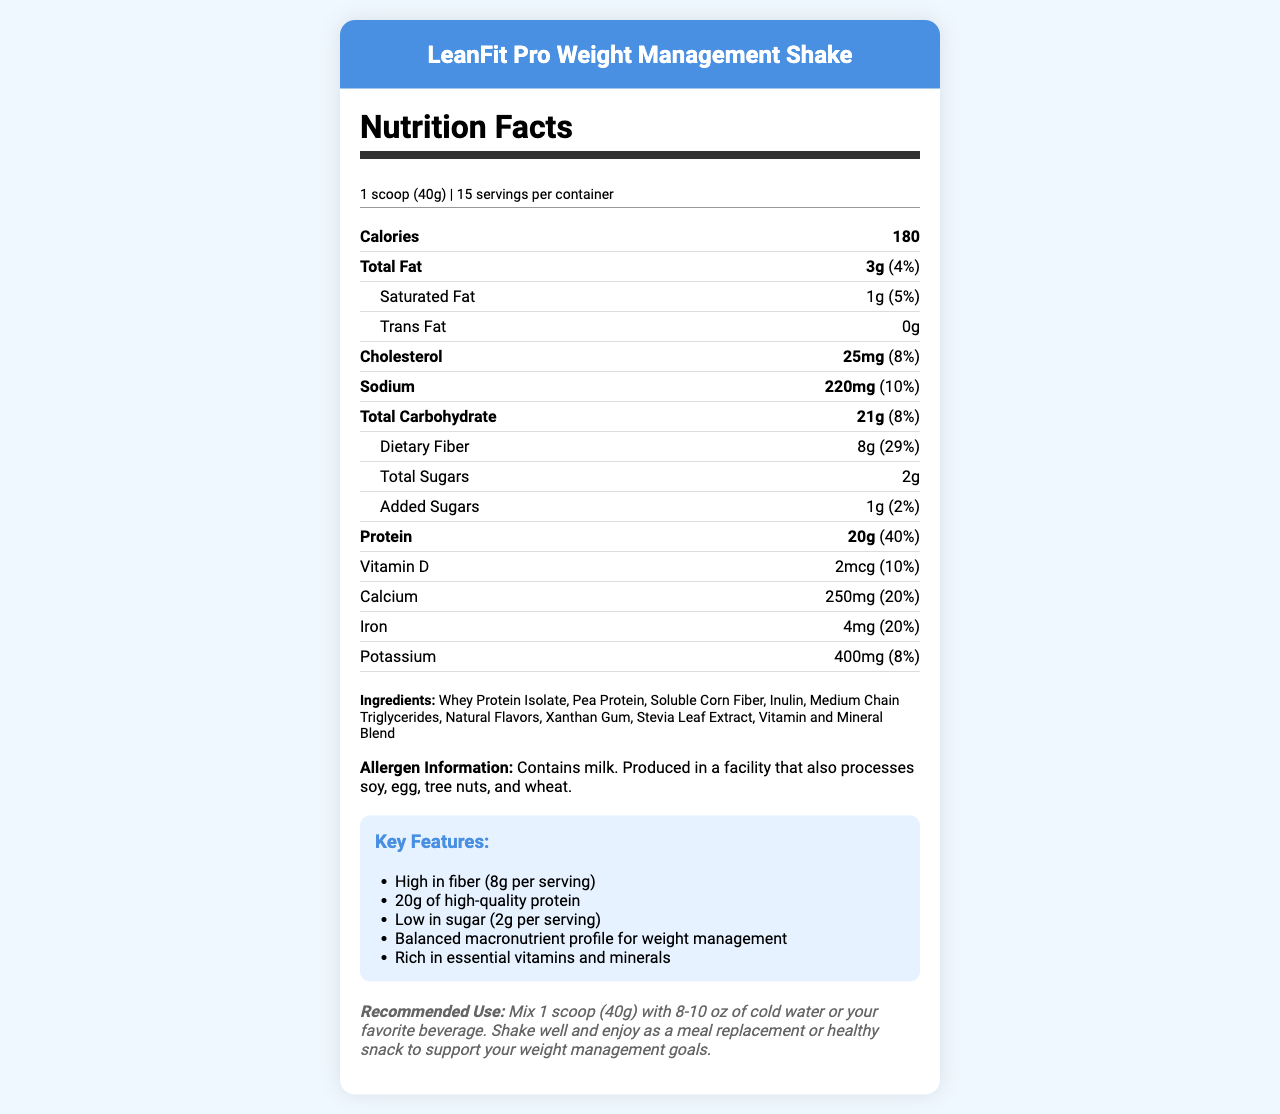what is the serving size? The serving size is stated at the top of the nutrition facts section as "1 scoop (40g)".
Answer: 1 scoop (40g) what is the amount of dietary fiber per serving? The amount of dietary fiber per serving is given in the nutrition facts as "8g".
Answer: 8g how many servings are there in the container? The number of servings per container is mentioned in the serving info as "15 servings per container".
Answer: 15 what percentage of the daily value is provided by protein per serving? The percentage of the daily value for protein is listed as "40%".
Answer: 40% what are the main sources of protein listed in the ingredients? The ingredients list includes "Whey Protein Isolate" and "Pea Protein" as the main sources of protein.
Answer: Whey Protein Isolate, Pea Protein which of the following is not an ingredient in this product? A. Soluble Corn Fiber B. Natural Flavors C. Artificial Colors D. Stevia Leaf Extract The ingredients list includes Soluble Corn Fiber, Natural Flavors, and Stevia Leaf Extract, but not Artificial Colors.
Answer: C how much vitamin C is in each serving? A. 10mg B. 30mg C. 50mg D. 2mcg The nutrition facts list "Vitamin C" as providing 30mg per serving.
Answer: B is this product high in fiber? The key features highlight "High in fiber (8g per serving)".
Answer: Yes summarize the key features of the product. The key features section lists these attributes, showcasing the benefits of the product as high fiber, high protein, low sugar, balanced macronutrient profile, and richness in essential vitamins and minerals.
Answer: High in fiber (8g per serving), 20g of high-quality protein, Low in sugar (2g per serving), Balanced macronutrient profile for weight management, Rich in essential vitamins and minerals how many calories are there in one serving? The document states that each serving contains 180 calories in the nutrition facts section.
Answer: 180 what is the recommended use of this product? The recommended use of the product is detailed at the bottom of the document.
Answer: Mix 1 scoop (40g) with 8-10 oz of cold water or your favorite beverage. Shake well and enjoy as a meal replacement or healthy snack to support your weight management goals. what percentage of Daily Value (DV) does selenium provide per serving? The nutrition facts list selenium as providing 60% of the daily value per serving.
Answer: 60% is there any copper in this product? If so, how much? The nutrition facts list copper with an amount of 0.9mg per serving.
Answer: Yes, 0.9mg can we determine from the document whether the product is gluten-free? The document does not explicitly state whether the product is gluten-free. It mentions allergens like milk, soy, egg, tree nuts, and wheat processing, but does not conclusively say the product is gluten-free.
Answer: Not enough information 